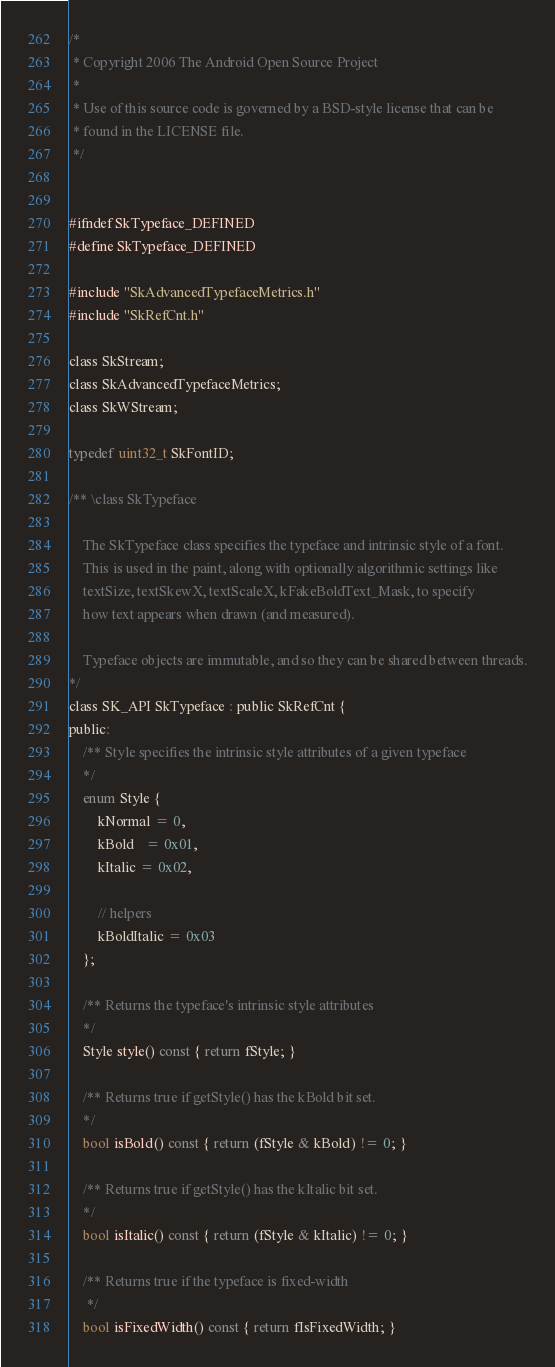<code> <loc_0><loc_0><loc_500><loc_500><_C_>
/*
 * Copyright 2006 The Android Open Source Project
 *
 * Use of this source code is governed by a BSD-style license that can be
 * found in the LICENSE file.
 */


#ifndef SkTypeface_DEFINED
#define SkTypeface_DEFINED

#include "SkAdvancedTypefaceMetrics.h"
#include "SkRefCnt.h"

class SkStream;
class SkAdvancedTypefaceMetrics;
class SkWStream;

typedef uint32_t SkFontID;

/** \class SkTypeface

    The SkTypeface class specifies the typeface and intrinsic style of a font.
    This is used in the paint, along with optionally algorithmic settings like
    textSize, textSkewX, textScaleX, kFakeBoldText_Mask, to specify
    how text appears when drawn (and measured).

    Typeface objects are immutable, and so they can be shared between threads.
*/
class SK_API SkTypeface : public SkRefCnt {
public:
    /** Style specifies the intrinsic style attributes of a given typeface
    */
    enum Style {
        kNormal = 0,
        kBold   = 0x01,
        kItalic = 0x02,

        // helpers
        kBoldItalic = 0x03
    };

    /** Returns the typeface's intrinsic style attributes
    */
    Style style() const { return fStyle; }

    /** Returns true if getStyle() has the kBold bit set.
    */
    bool isBold() const { return (fStyle & kBold) != 0; }

    /** Returns true if getStyle() has the kItalic bit set.
    */
    bool isItalic() const { return (fStyle & kItalic) != 0; }

    /** Returns true if the typeface is fixed-width
     */
    bool isFixedWidth() const { return fIsFixedWidth; }
</code> 